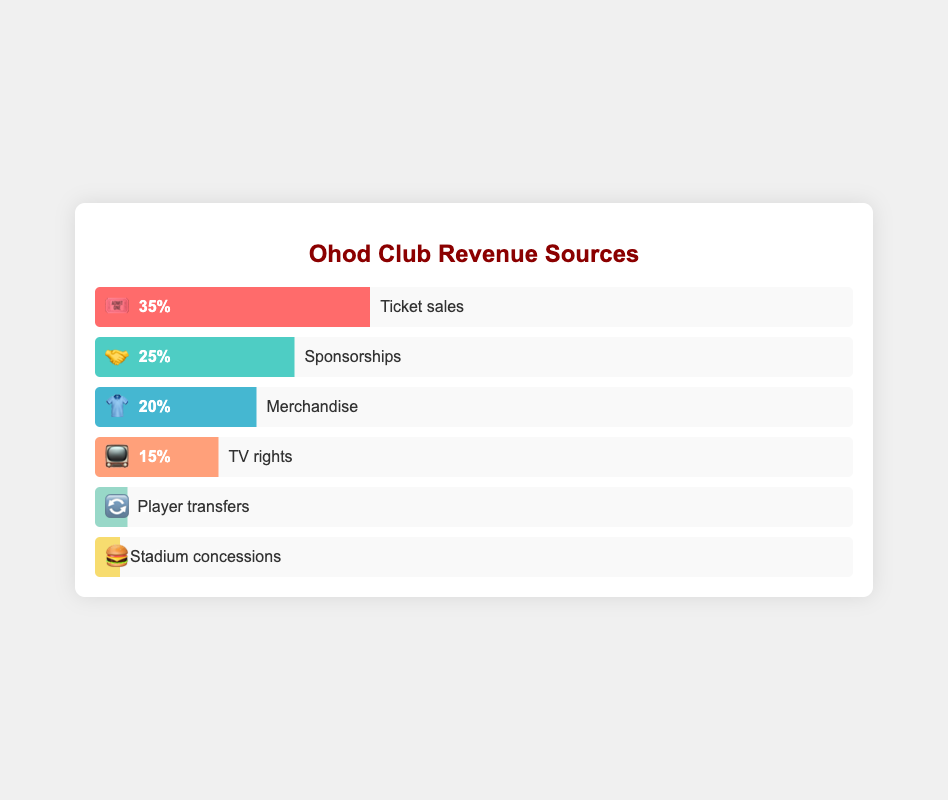Which revenue source contributes the most to Ohod Club’s revenue? The chart shows that "Ticket sales" has the highest percentage at 35%, which is more than any other revenue source.
Answer: Ticket sales What is the combined revenue percentage from Sponsorships and Merchandise? Add the percentages of Sponsorships (25%) and Merchandise (20%): 25% + 20% = 45%
Answer: 45% Which revenue source has the smallest contribution to Ohod Club’s revenue? The chart indicates that "Stadium concessions" has the smallest percentage at 2%, which is the lowest of all sources.
Answer: Stadium concessions By how much does the percentage of Ticket sales exceed that of TV rights? Subtract the percentage of TV rights (15%) from Ticket sales (35%): 35% - 15% = 20%
Answer: 20% Compare the revenue contribution between Merchandise and Player transfers. Which one is higher and by how much? Merchandise contributes 20% and Player transfers contribute 3%. Subtract 3% from 20% to find the difference: 20% - 3% = 17%
Answer: Merchandise by 17% If Sponsorships and TV rights revenue were combined, would they surpass Ticket sales? Combine the percentages of Sponsorships (25%) and TV rights (15%): 25% + 15% = 40%. Compare this with Ticket sales (35%). Since 40% > 35%, the combined revenue would surpass Ticket sales.
Answer: Yes What is the percentage difference between the highest and lowest revenue sources? Subtract the lowest percentage (Stadium concessions at 2%) from the highest percentage (Ticket sales at 35%): 35% - 2% = 33%
Answer: 33% How many revenue sources contribute at least 15% to Ohod Club’s revenue? Ticket sales (35%), Sponsorships (25%), Merchandise (20%), and TV rights (15%) each contribute at least 15%. There are 4 such sources.
Answer: 4 Which revenue source contributes more to the club’s revenue, Merchandise or TV rights, and by how much? Merchandise contributes 20% and TV rights contribute 15%. Subtract 15% from 20% to find the difference: 20% - 15% = 5%
Answer: Merchandise by 5% 